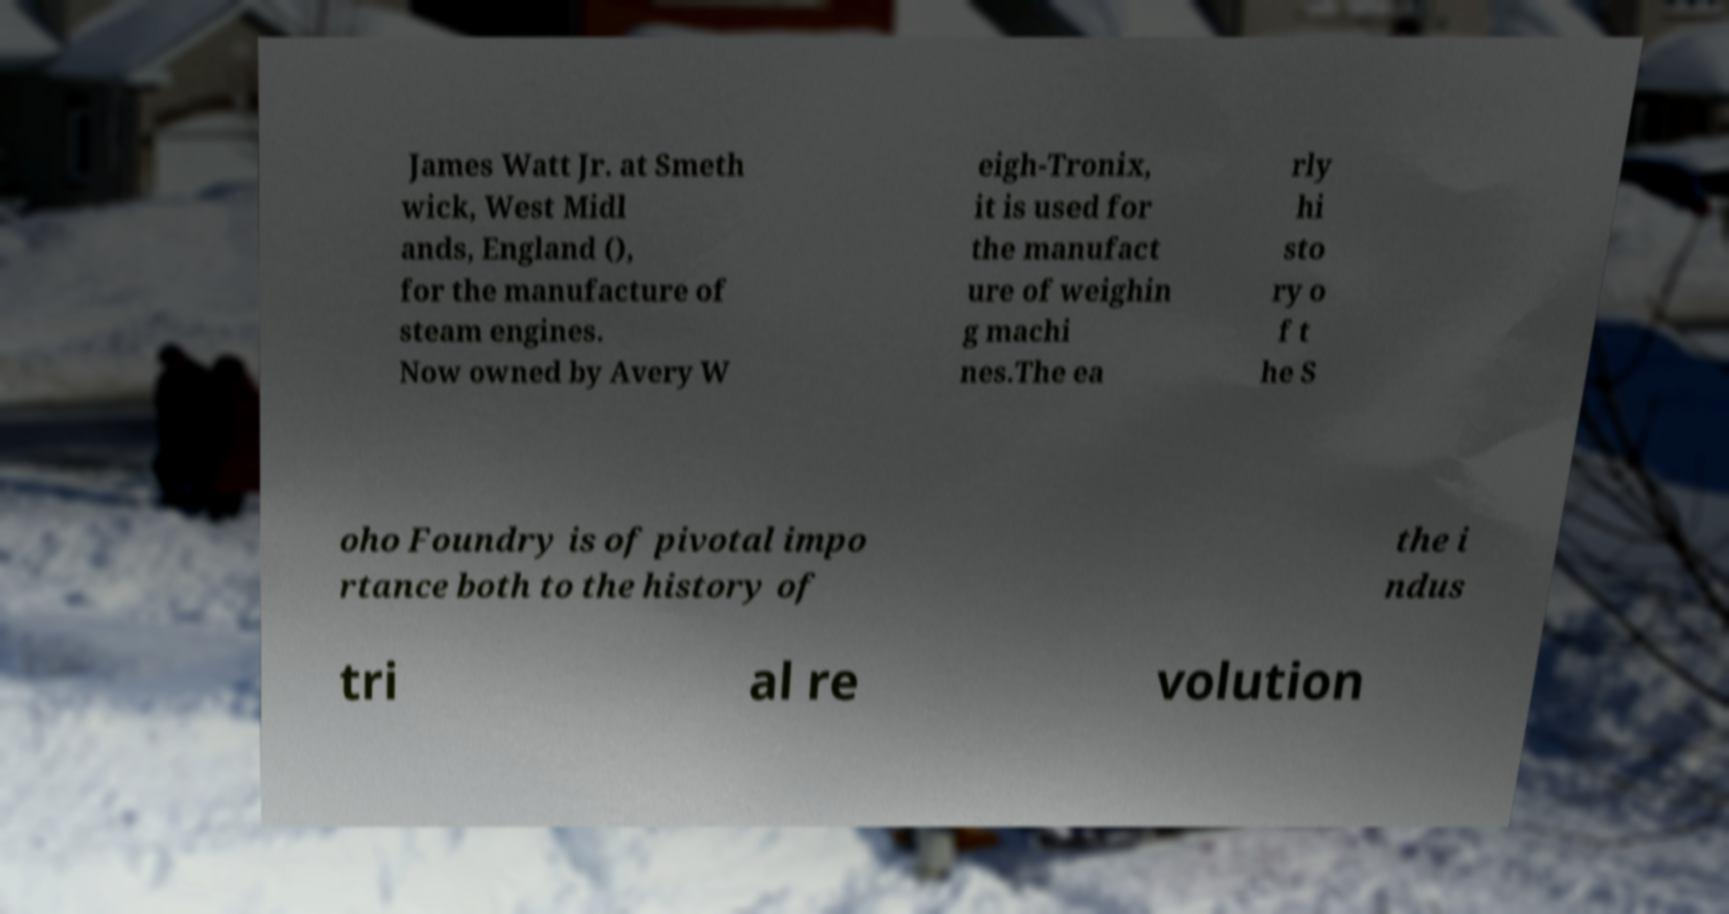Please identify and transcribe the text found in this image. James Watt Jr. at Smeth wick, West Midl ands, England (), for the manufacture of steam engines. Now owned by Avery W eigh-Tronix, it is used for the manufact ure of weighin g machi nes.The ea rly hi sto ry o f t he S oho Foundry is of pivotal impo rtance both to the history of the i ndus tri al re volution 